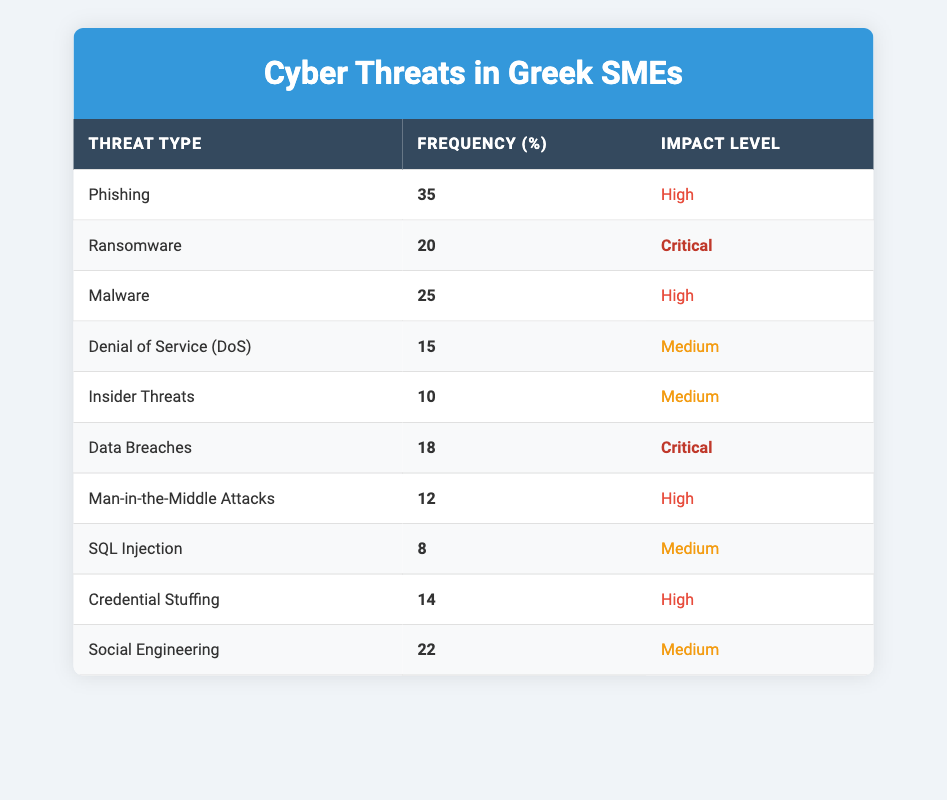What is the most frequent type of cyber threat encountered by SMEs in Greece? The table shows that Phishing has the highest frequency, which is 35%. This can be observed as it is listed first under the frequency column and has the maximum value.
Answer: Phishing How many types of cyber threats have a Critical impact level? There are two threats with a Critical impact level: Ransomware and Data Breaches. Counting these from the table gives us the answer.
Answer: 2 What is the total frequency of all cyber threats listed? To find the total frequency, we sum up all the frequencies from the table: 35 + 20 + 25 + 15 + 10 + 18 + 12 + 8 + 14 + 22 =  169.
Answer: 169 Is the frequency of Credential Stuffing greater than Malware? Credential Stuffing has a frequency of 14% while Malware has a frequency of 25%. Since 14 is less than 25, the statement is false.
Answer: No Which cyber threat has the lowest frequency and what is its impact level? From the table, SQL Injection has the lowest frequency at 8% and its impact level is Medium. This can be verified by looking at the last row of the frequency column.
Answer: SQL Injection, Medium What is the average frequency of cyber threats with a High impact level? There are four threats with High impact levels: Phishing (35), Malware (25), Man-in-the-Middle Attacks (12), and Credential Stuffing (14). The sum is 35 + 25 + 12 + 14 = 86. The average is calculated by dividing this sum by 4, giving us 86/4 = 21.5.
Answer: 21.5 Are there more types of threats with a Medium impact level than with a High impact level? The table shows 4 threats classified as Medium (Denial of Service, Insider Threats, SQL Injection, and Social Engineering) and 4 classified as High (Phishing, Malware, Man-in-the-Middle Attacks, and Credential Stuffing). Since the counts are equal, the answer is no.
Answer: No What is the impact level of the second most frequent cyber threat? The second most frequent threat is Ransomware with a frequency of 20%. Its impact level is classified as Critical as shown in the table.
Answer: Critical 